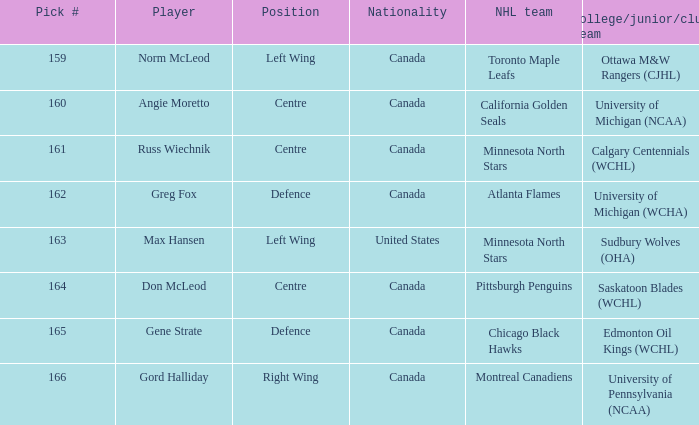Who came from the University of Michigan (NCAA) team? Angie Moretto. 